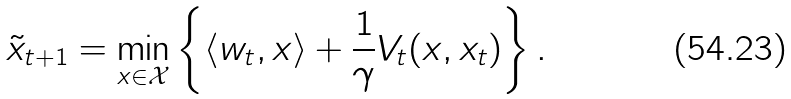<formula> <loc_0><loc_0><loc_500><loc_500>\tilde { x } _ { t + 1 } = \min _ { x \in \mathcal { X } } \left \{ \langle w _ { t } , x \rangle + \frac { 1 } { \gamma } V _ { t } ( x , x _ { t } ) \right \} .</formula> 